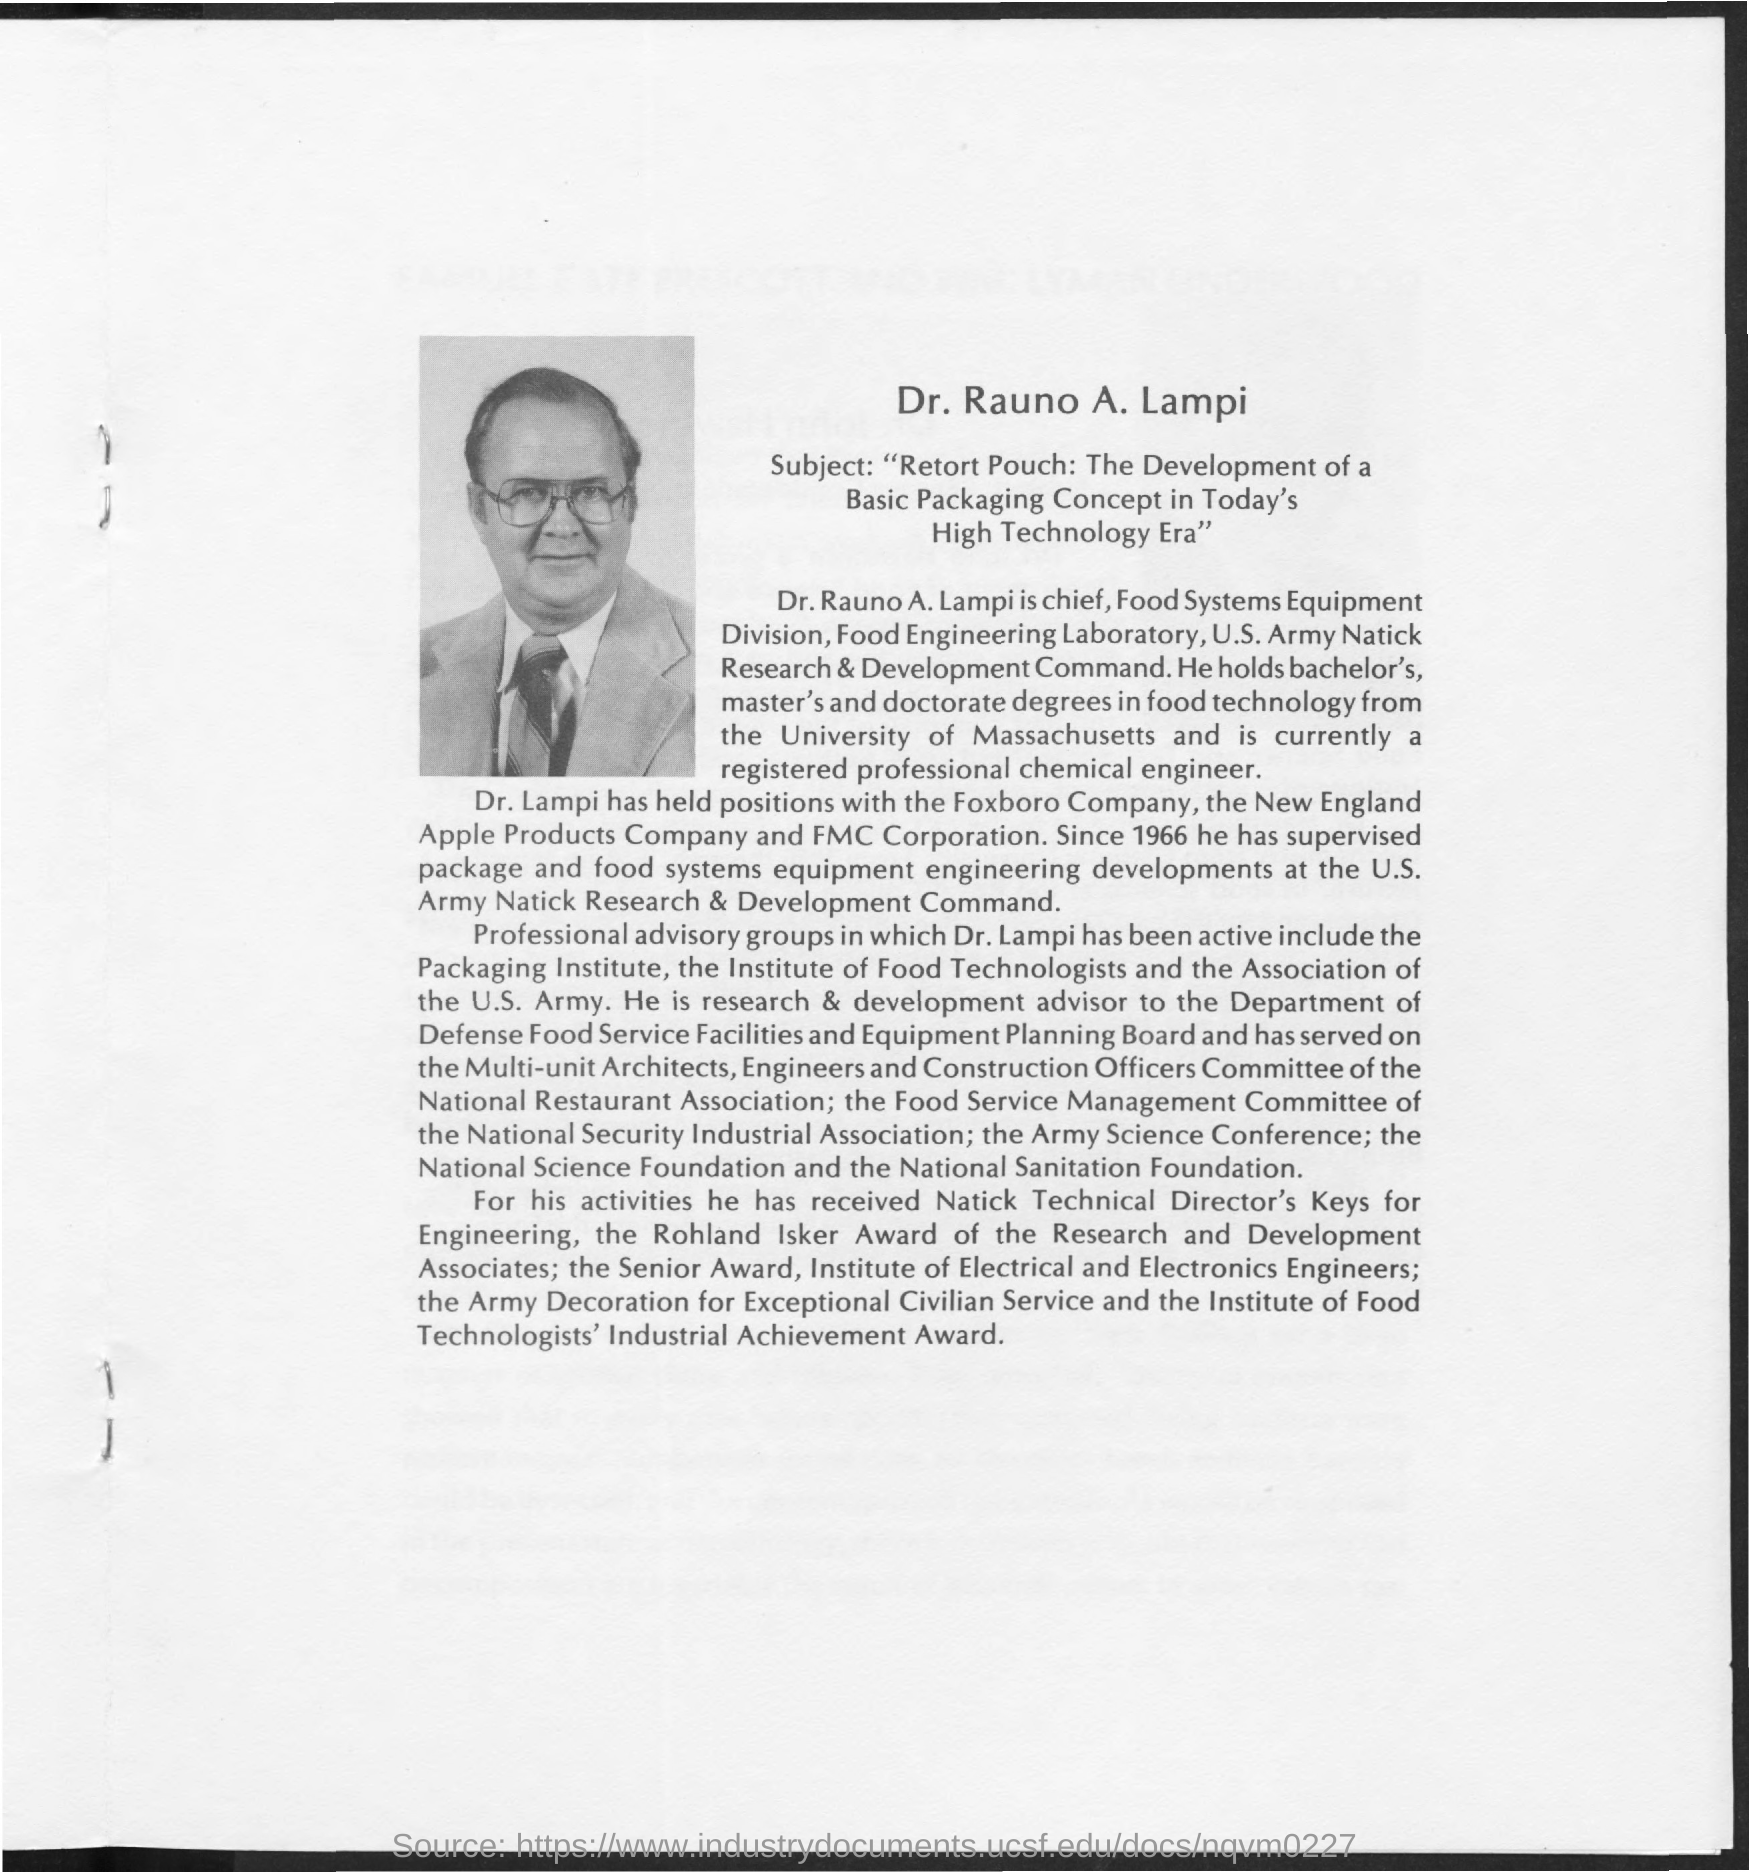Who is the Chief of Food Systems Equipment Division?
Offer a very short reply. Dr. Rauno A. Lampi. 